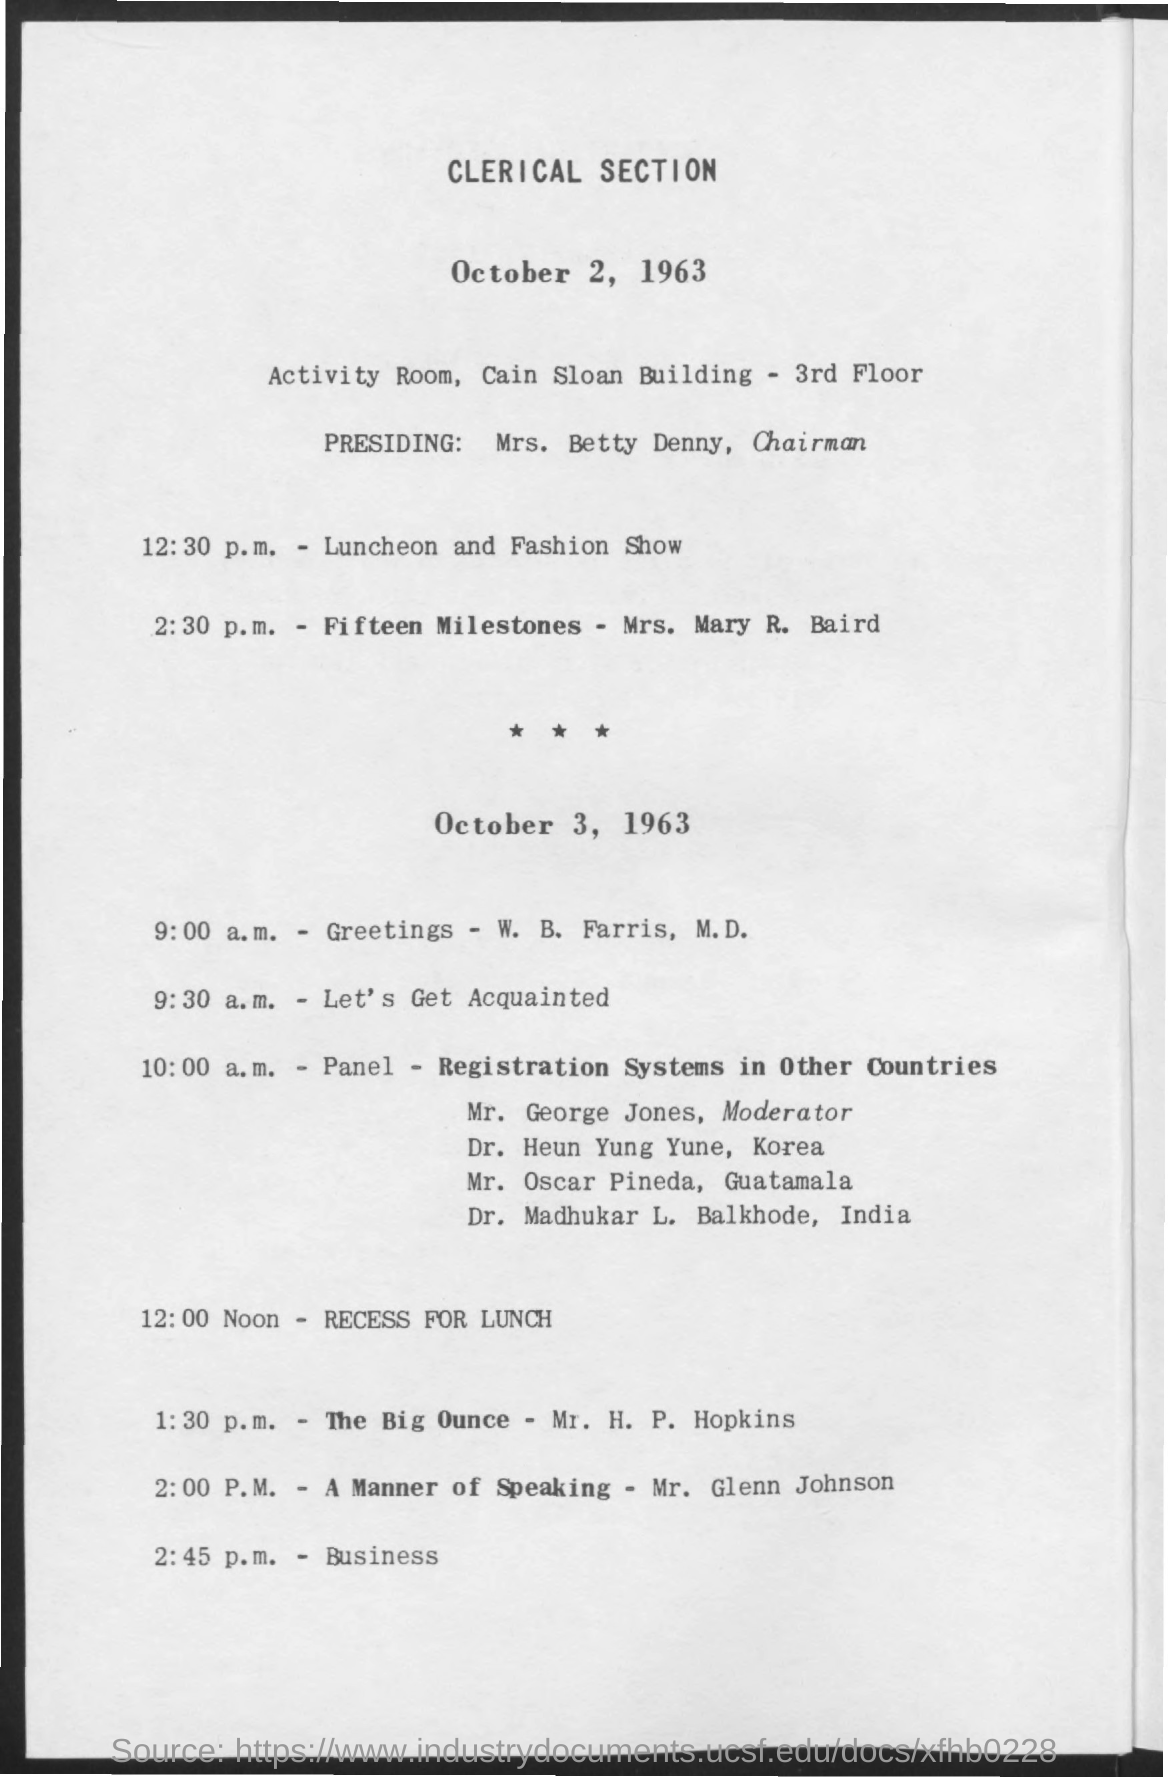What is the first title in the document?
Keep it short and to the point. Clerical Section. 